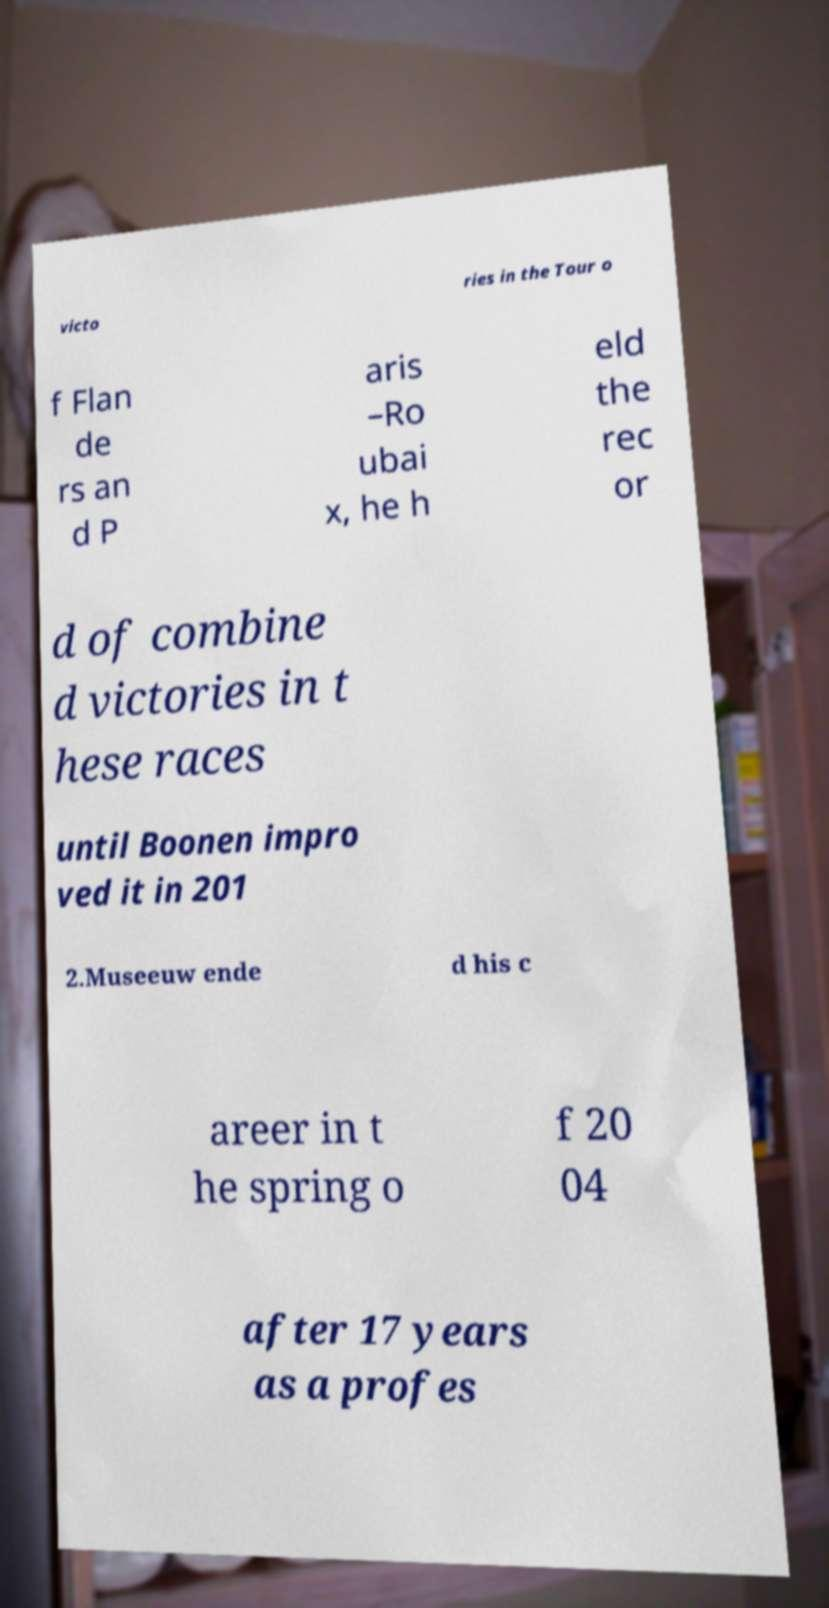There's text embedded in this image that I need extracted. Can you transcribe it verbatim? victo ries in the Tour o f Flan de rs an d P aris –Ro ubai x, he h eld the rec or d of combine d victories in t hese races until Boonen impro ved it in 201 2.Museeuw ende d his c areer in t he spring o f 20 04 after 17 years as a profes 